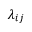Convert formula to latex. <formula><loc_0><loc_0><loc_500><loc_500>\lambda _ { i j }</formula> 